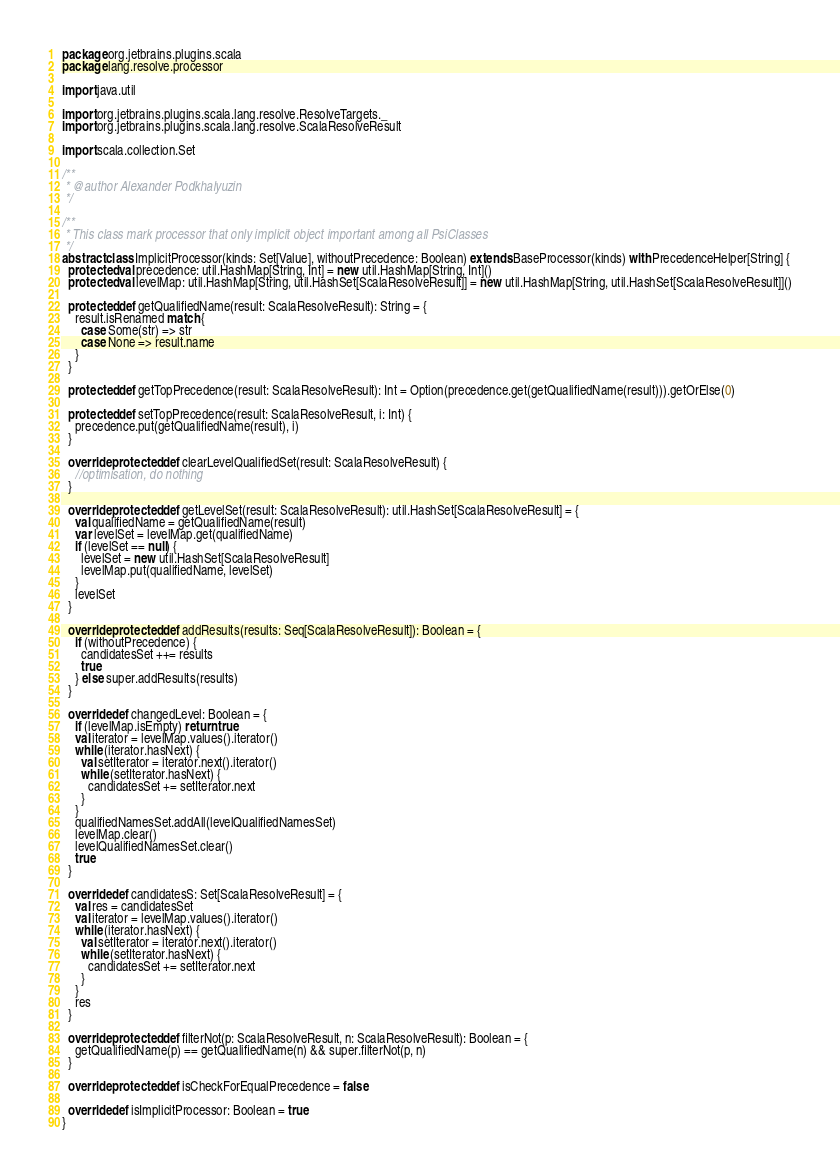Convert code to text. <code><loc_0><loc_0><loc_500><loc_500><_Scala_>package org.jetbrains.plugins.scala
package lang.resolve.processor

import java.util

import org.jetbrains.plugins.scala.lang.resolve.ResolveTargets._
import org.jetbrains.plugins.scala.lang.resolve.ScalaResolveResult

import scala.collection.Set

/**
 * @author Alexander Podkhalyuzin
 */

/**
 * This class mark processor that only implicit object important among all PsiClasses
 */
abstract class ImplicitProcessor(kinds: Set[Value], withoutPrecedence: Boolean) extends BaseProcessor(kinds) with PrecedenceHelper[String] {
  protected val precedence: util.HashMap[String, Int] = new util.HashMap[String, Int]()
  protected val levelMap: util.HashMap[String, util.HashSet[ScalaResolveResult]] = new util.HashMap[String, util.HashSet[ScalaResolveResult]]()

  protected def getQualifiedName(result: ScalaResolveResult): String = {
    result.isRenamed match {
      case Some(str) => str
      case None => result.name
    }
  }

  protected def getTopPrecedence(result: ScalaResolveResult): Int = Option(precedence.get(getQualifiedName(result))).getOrElse(0)

  protected def setTopPrecedence(result: ScalaResolveResult, i: Int) {
    precedence.put(getQualifiedName(result), i)
  }

  override protected def clearLevelQualifiedSet(result: ScalaResolveResult) {
    //optimisation, do nothing
  }

  override protected def getLevelSet(result: ScalaResolveResult): util.HashSet[ScalaResolveResult] = {
    val qualifiedName = getQualifiedName(result)
    var levelSet = levelMap.get(qualifiedName)
    if (levelSet == null) {
      levelSet = new util.HashSet[ScalaResolveResult]
      levelMap.put(qualifiedName, levelSet)
    }
    levelSet
  }

  override protected def addResults(results: Seq[ScalaResolveResult]): Boolean = {
    if (withoutPrecedence) {
      candidatesSet ++= results
      true
    } else super.addResults(results)
  }

  override def changedLevel: Boolean = {
    if (levelMap.isEmpty) return true
    val iterator = levelMap.values().iterator()
    while (iterator.hasNext) {
      val setIterator = iterator.next().iterator()
      while (setIterator.hasNext) {
        candidatesSet += setIterator.next
      }
    }
    qualifiedNamesSet.addAll(levelQualifiedNamesSet)
    levelMap.clear()
    levelQualifiedNamesSet.clear()
    true
  }

  override def candidatesS: Set[ScalaResolveResult] = {
    val res = candidatesSet
    val iterator = levelMap.values().iterator()
    while (iterator.hasNext) {
      val setIterator = iterator.next().iterator()
      while (setIterator.hasNext) {
        candidatesSet += setIterator.next
      }
    }
    res
  }

  override protected def filterNot(p: ScalaResolveResult, n: ScalaResolveResult): Boolean = {
    getQualifiedName(p) == getQualifiedName(n) && super.filterNot(p, n)
  }

  override protected def isCheckForEqualPrecedence = false

  override def isImplicitProcessor: Boolean = true
}</code> 